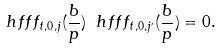<formula> <loc_0><loc_0><loc_500><loc_500>\ h f f f _ { t , 0 , j } ( \frac { b } p ) \ h f f f _ { t , 0 , j ^ { \prime } } ( \frac { b } p ) = 0 .</formula> 